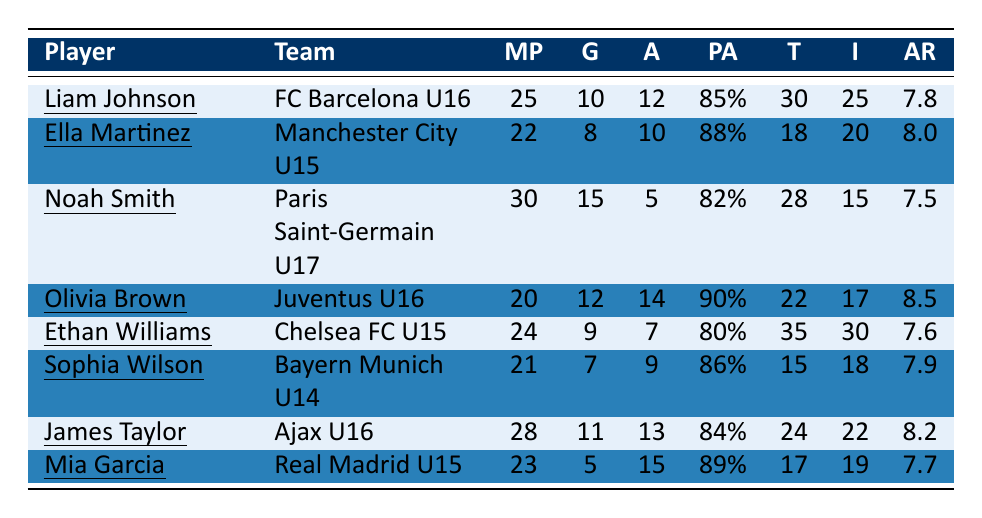What is the highest pass accuracy among the players? The pass accuracy values are: 85%, 88%, 82%, 90%, 80%, 86%, 84%, and 89%. The highest value is 90%.
Answer: 90% Who scored the most goals in the table? The goals scored by each player are: 10, 8, 15, 12, 9, 7, 11, and 5. The highest value is 15 by Noah Smith.
Answer: Noah Smith What is the average rating of Olivia Brown? The average rating for Olivia Brown is listed as 8.5 in the table.
Answer: 8.5 Which player has the most assists? The assists are: 12, 10, 5, 14, 7, 9, 13, and 15. The highest number of assists is 15 by Mia Garcia.
Answer: Mia Garcia What is the combined total of goals scored by Liam Johnson and James Taylor? Liam Johnson scored 10 goals and James Taylor scored 11 goals. The total is 10 + 11 = 21.
Answer: 21 Which player has the lowest average rating? The average ratings listed are: 7.8, 8.0, 7.5, 8.5, 7.6, 7.9, 8.2, and 7.7. The lowest is 7.5 by Noah Smith.
Answer: Noah Smith Which player has played the least matches and what is that number? The matches played by each player are: 25, 22, 30, 20, 24, 21, 28, and 23. The least is 20 by Olivia Brown.
Answer: 20 What is the total number of tackles made by all players? The tackles are: 30, 18, 28, 22, 35, 15, 24, and 17. Adding these gives: 30 + 18 + 28 + 22 + 35 + 15 + 24 + 17 = 189.
Answer: 189 How many players have an average rating of 8 or above? The ratings 8.0, 8.5, 8.2, and 7.9 are the ratings that are equal or above 8. This counts as 4 players.
Answer: 4 Is it true that all players have a pass accuracy of 80% or higher? The pass accuracy percentages are 85%, 88%, 82%, 90%, 80%, 86%, 84%, and 89%. Since all are 80% or higher, this statement is true.
Answer: Yes Which player has the highest number of interceptions and how many? The number of interceptions are: 25, 20, 15, 17, 30, 18, 22, and 19. The highest is 30 by Ethan Williams.
Answer: Ethan Williams, 30 How does the total number of assists for Noah Smith compare to the total for Ella Martinez? Noah Smith has 5 assists and Ella Martinez has 10. The comparison shows Noah Smith has 5 less than Ella Martinez.
Answer: 5 less What is the overall average of passes completed (pass accuracy) among the players in percentage? The pass accuracy percentages are: 85%, 88%, 82%, 90%, 80%, 86%, 84%, and 89%. The average is calculated as (85 + 88 + 82 + 90 + 80 + 86 + 84 + 89) / 8 = 86.
Answer: 86% Among the players, who has a ratio of goals to assists closest to 1? Checking the ratios: Liam Johnson: 10/12 = 0.83, Ella Martinez: 8/10 = 0.8, Noah Smith: 15/5 = 3, Olivia Brown: 12/14 = 0.86, Ethan Williams: 9/7 = 1.29, Sophia Wilson: 7/9 = 0.78, James Taylor: 11/13 = 0.85, Mia Garcia: 5/15 = 0.33. The closest ratio to 1 is for Ethan Williams at 1.29.
Answer: Ethan Williams 